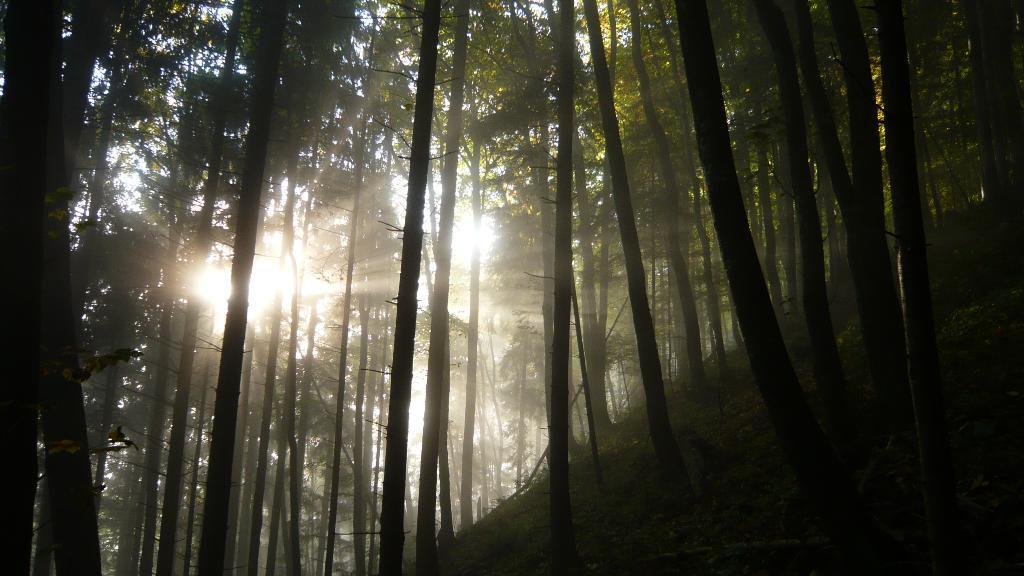Can you describe this image briefly? In the foreground of this image, there are trees. In the background, there is the sun and the rays. 